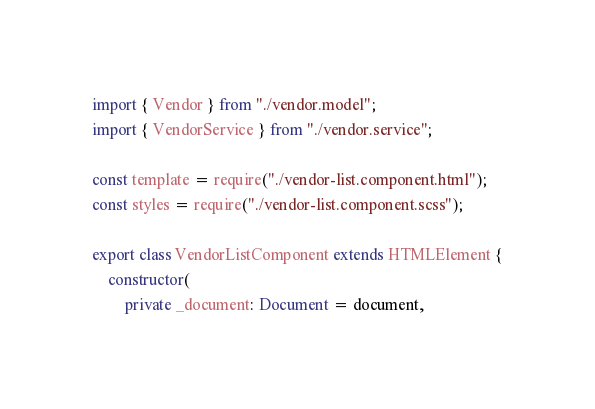<code> <loc_0><loc_0><loc_500><loc_500><_TypeScript_>import { Vendor } from "./vendor.model";
import { VendorService } from "./vendor.service";

const template = require("./vendor-list.component.html");
const styles = require("./vendor-list.component.scss");

export class VendorListComponent extends HTMLElement {
    constructor(
		private _document: Document = document,</code> 